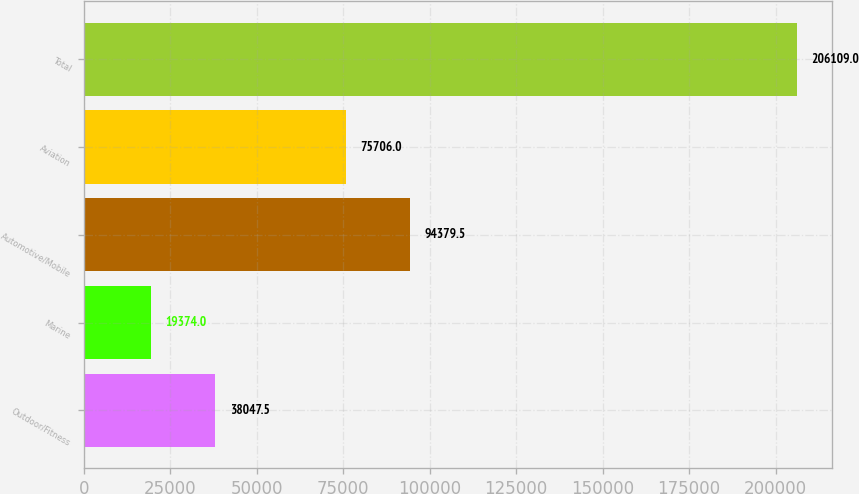Convert chart. <chart><loc_0><loc_0><loc_500><loc_500><bar_chart><fcel>Outdoor/Fitness<fcel>Marine<fcel>Automotive/Mobile<fcel>Aviation<fcel>Total<nl><fcel>38047.5<fcel>19374<fcel>94379.5<fcel>75706<fcel>206109<nl></chart> 